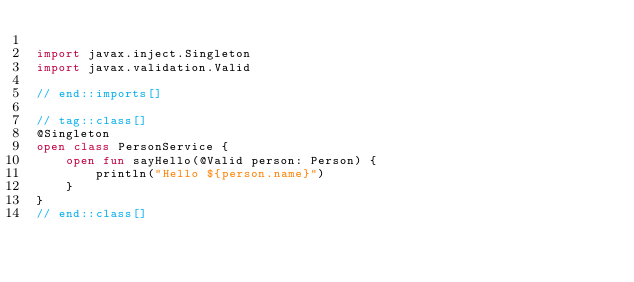Convert code to text. <code><loc_0><loc_0><loc_500><loc_500><_Kotlin_>
import javax.inject.Singleton
import javax.validation.Valid

// end::imports[]

// tag::class[]
@Singleton
open class PersonService {
    open fun sayHello(@Valid person: Person) {
        println("Hello ${person.name}")
    }
}
// end::class[]
</code> 